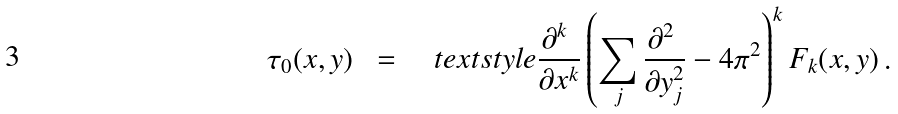Convert formula to latex. <formula><loc_0><loc_0><loc_500><loc_500>\tau _ { 0 } ( x , y ) \ \ = \quad t e x t s t y l e \frac { \partial ^ { k } \ } { \partial x ^ { k } } \left ( \sum _ { j } \frac { \partial ^ { 2 } \ } { \partial y _ { j } ^ { 2 } } - 4 \pi ^ { 2 } \right ) ^ { k } F _ { k } ( x , y ) \, .</formula> 